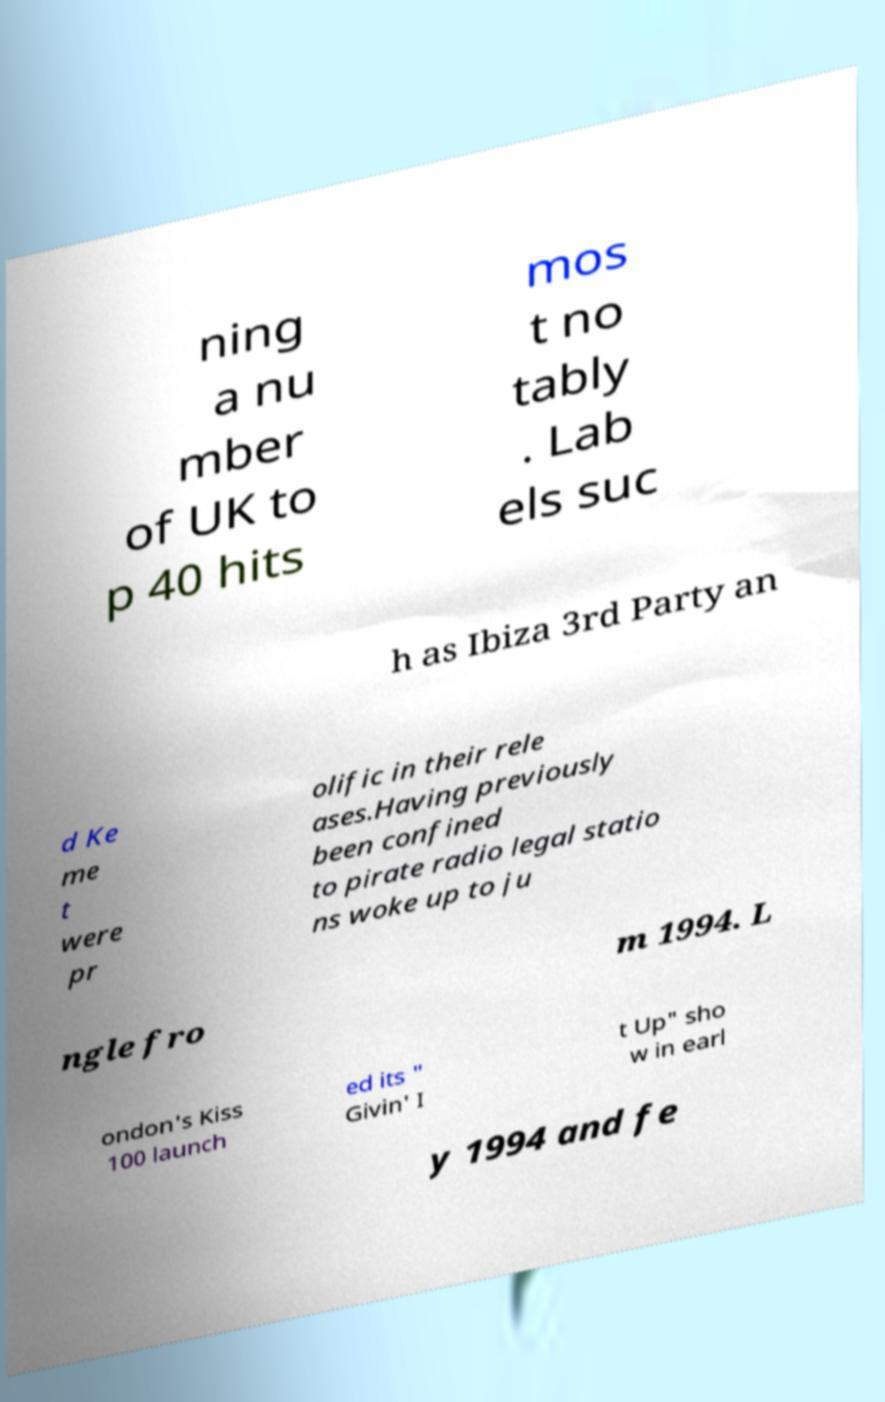For documentation purposes, I need the text within this image transcribed. Could you provide that? ning a nu mber of UK to p 40 hits mos t no tably . Lab els suc h as Ibiza 3rd Party an d Ke me t were pr olific in their rele ases.Having previously been confined to pirate radio legal statio ns woke up to ju ngle fro m 1994. L ondon's Kiss 100 launch ed its " Givin' I t Up" sho w in earl y 1994 and fe 